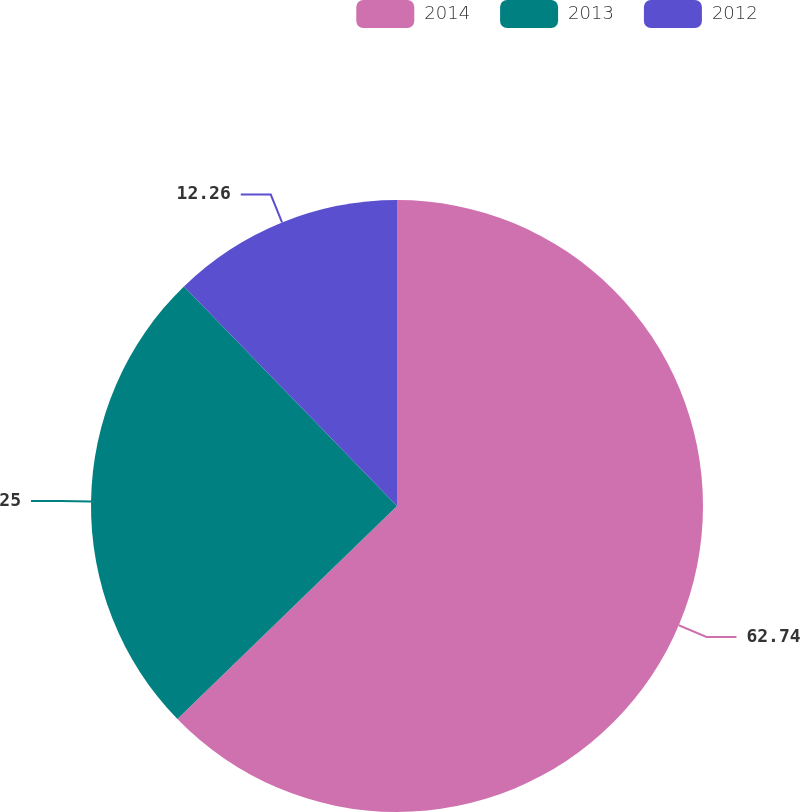<chart> <loc_0><loc_0><loc_500><loc_500><pie_chart><fcel>2014<fcel>2013<fcel>2012<nl><fcel>62.74%<fcel>25.0%<fcel>12.26%<nl></chart> 